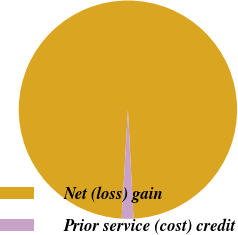Convert chart to OTSL. <chart><loc_0><loc_0><loc_500><loc_500><pie_chart><fcel>Net (loss) gain<fcel>Prior service (cost) credit<nl><fcel>98.27%<fcel>1.73%<nl></chart> 